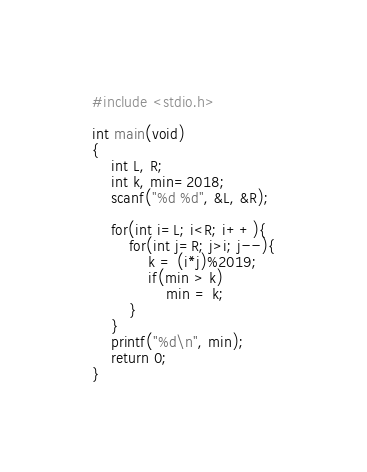<code> <loc_0><loc_0><loc_500><loc_500><_C_>#include <stdio.h>

int main(void)
{
    int L, R;
    int k, min=2018;
    scanf("%d %d", &L, &R);

    for(int i=L; i<R; i++){
        for(int j=R; j>i; j--){
            k = (i*j)%2019;
            if(min > k)
                min = k;
        }
    }
    printf("%d\n", min);
    return 0;
}</code> 